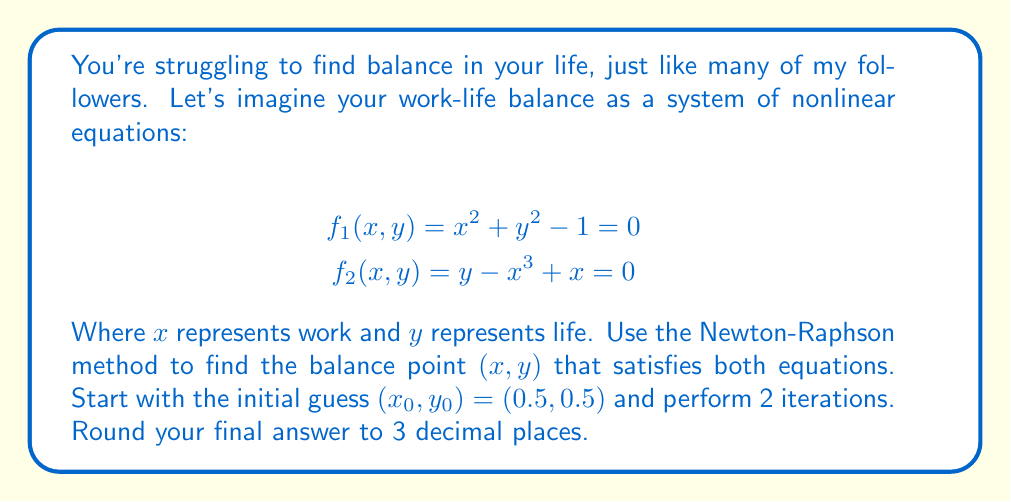Could you help me with this problem? Let's tackle this step-by-step, just like we tackle life's challenges:

1) The Newton-Raphson method for a system of two equations is:

   $$\begin{bmatrix} x_{n+1} \\ y_{n+1} \end{bmatrix} = \begin{bmatrix} x_n \\ y_n \end{bmatrix} - J^{-1}(x_n,y_n) \begin{bmatrix} f_1(x_n,y_n) \\ f_2(x_n,y_n) \end{bmatrix}$$

   Where $J$ is the Jacobian matrix:

   $$J = \begin{bmatrix} 
   \frac{\partial f_1}{\partial x} & \frac{\partial f_1}{\partial y} \\
   \frac{\partial f_2}{\partial x} & \frac{\partial f_2}{\partial y}
   \end{bmatrix}$$

2) Calculate the Jacobian:

   $$J = \begin{bmatrix} 
   2x & 2y \\
   -3x^2 + 1 & 1
   \end{bmatrix}$$

3) For the first iteration $(n=0)$:
   
   $x_0 = 0.5$, $y_0 = 0.5$

   $$J(0.5,0.5) = \begin{bmatrix} 
   1 & 1 \\
   0.25 & 1
   \end{bmatrix}$$

   $$J^{-1}(0.5,0.5) = \begin{bmatrix} 
   1.333 & -1.333 \\
   -0.333 & 1.333
   \end{bmatrix}$$

   $$\begin{bmatrix} f_1(0.5,0.5) \\ f_2(0.5,0.5) \end{bmatrix} = \begin{bmatrix} -0.5 \\ 0.375 \end{bmatrix}$$

   $$\begin{bmatrix} x_1 \\ y_1 \end{bmatrix} = \begin{bmatrix} 0.5 \\ 0.5 \end{bmatrix} - \begin{bmatrix} 1.333 & -1.333 \\ -0.333 & 1.333 \end{bmatrix} \begin{bmatrix} -0.5 \\ 0.375 \end{bmatrix} = \begin{bmatrix} 0.833 \\ 0.708 \end{bmatrix}$$

4) For the second iteration $(n=1)$:

   $x_1 = 0.833$, $y_1 = 0.708$

   $$J(0.833,0.708) = \begin{bmatrix} 
   1.666 & 1.416 \\
   -1.083 & 1
   \end{bmatrix}$$

   $$J^{-1}(0.833,0.708) = \begin{bmatrix} 
   0.774 & -1.095 \\
   0.837 & 1.292
   \end{bmatrix}$$

   $$\begin{bmatrix} f_1(0.833,0.708) \\ f_2(0.833,0.708) \end{bmatrix} = \begin{bmatrix} 0.201 \\ 0.009 \end{bmatrix}$$

   $$\begin{bmatrix} x_2 \\ y_2 \end{bmatrix} = \begin{bmatrix} 0.833 \\ 0.708 \end{bmatrix} - \begin{bmatrix} 0.774 & -1.095 \\ 0.837 & 1.292 \end{bmatrix} \begin{bmatrix} 0.201 \\ 0.009 \end{bmatrix} = \begin{bmatrix} 0.707 \\ 0.707 \end{bmatrix}$$

5) Rounding to 3 decimal places:
   $x_2 = 0.707$, $y_2 = 0.707$
Answer: (0.707, 0.707) 